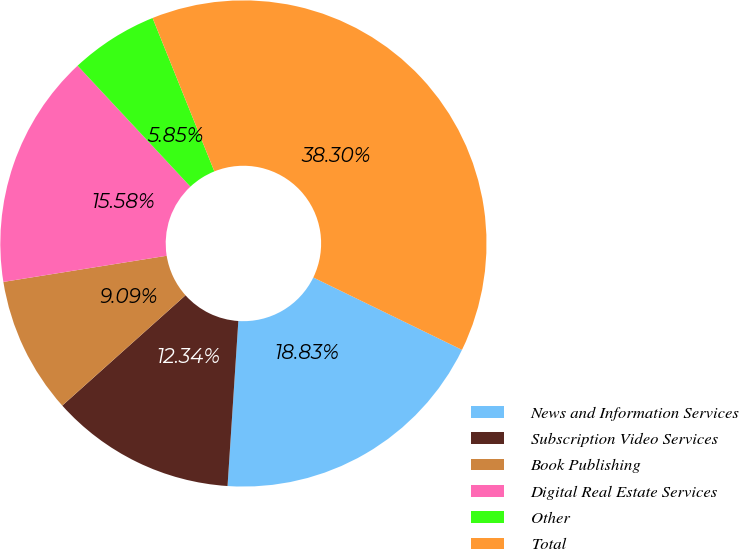<chart> <loc_0><loc_0><loc_500><loc_500><pie_chart><fcel>News and Information Services<fcel>Subscription Video Services<fcel>Book Publishing<fcel>Digital Real Estate Services<fcel>Other<fcel>Total<nl><fcel>18.83%<fcel>12.34%<fcel>9.09%<fcel>15.58%<fcel>5.85%<fcel>38.3%<nl></chart> 